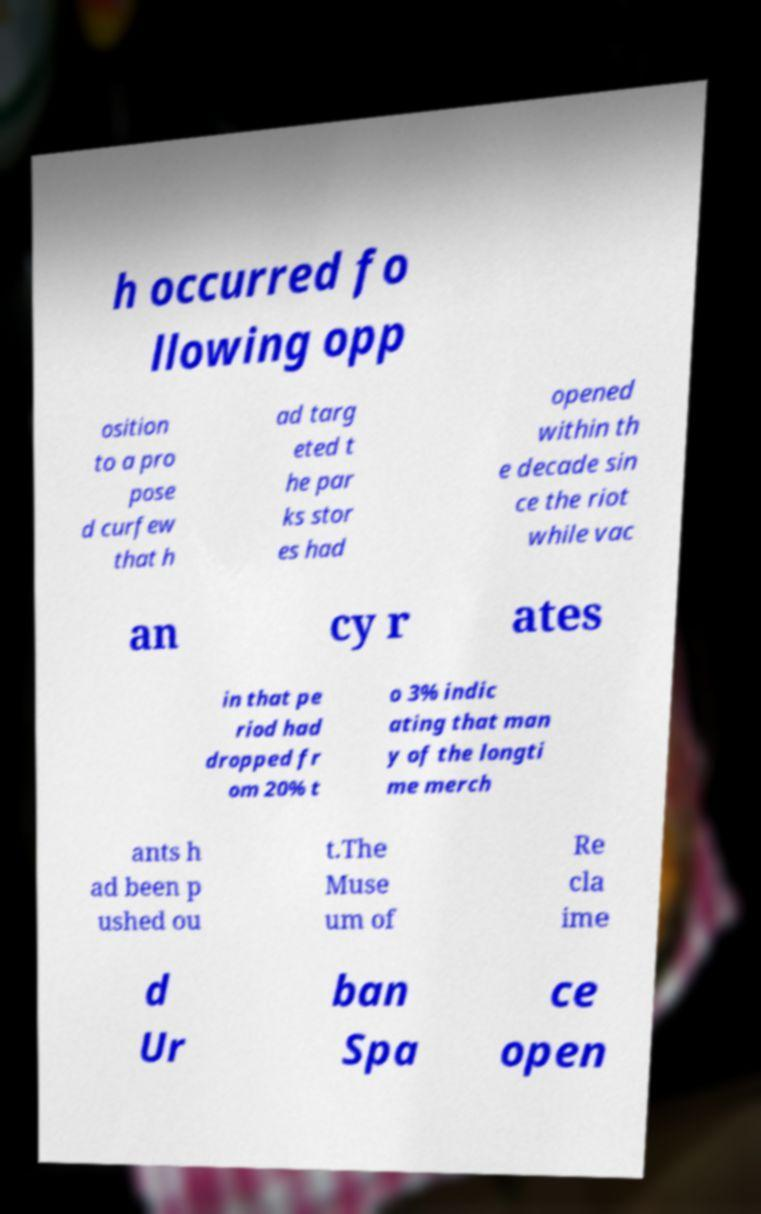Please identify and transcribe the text found in this image. h occurred fo llowing opp osition to a pro pose d curfew that h ad targ eted t he par ks stor es had opened within th e decade sin ce the riot while vac an cy r ates in that pe riod had dropped fr om 20% t o 3% indic ating that man y of the longti me merch ants h ad been p ushed ou t.The Muse um of Re cla ime d Ur ban Spa ce open 